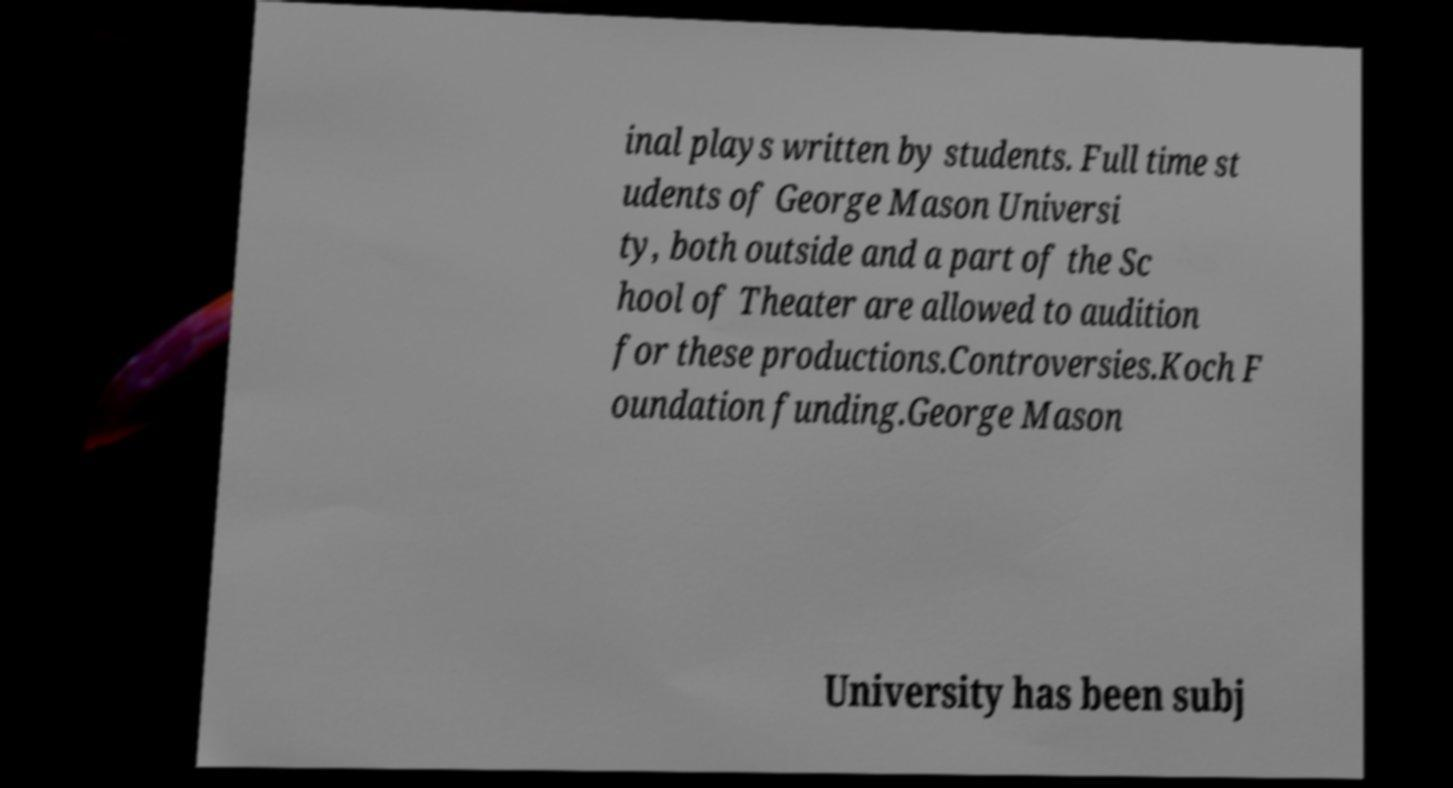Can you read and provide the text displayed in the image?This photo seems to have some interesting text. Can you extract and type it out for me? inal plays written by students. Full time st udents of George Mason Universi ty, both outside and a part of the Sc hool of Theater are allowed to audition for these productions.Controversies.Koch F oundation funding.George Mason University has been subj 